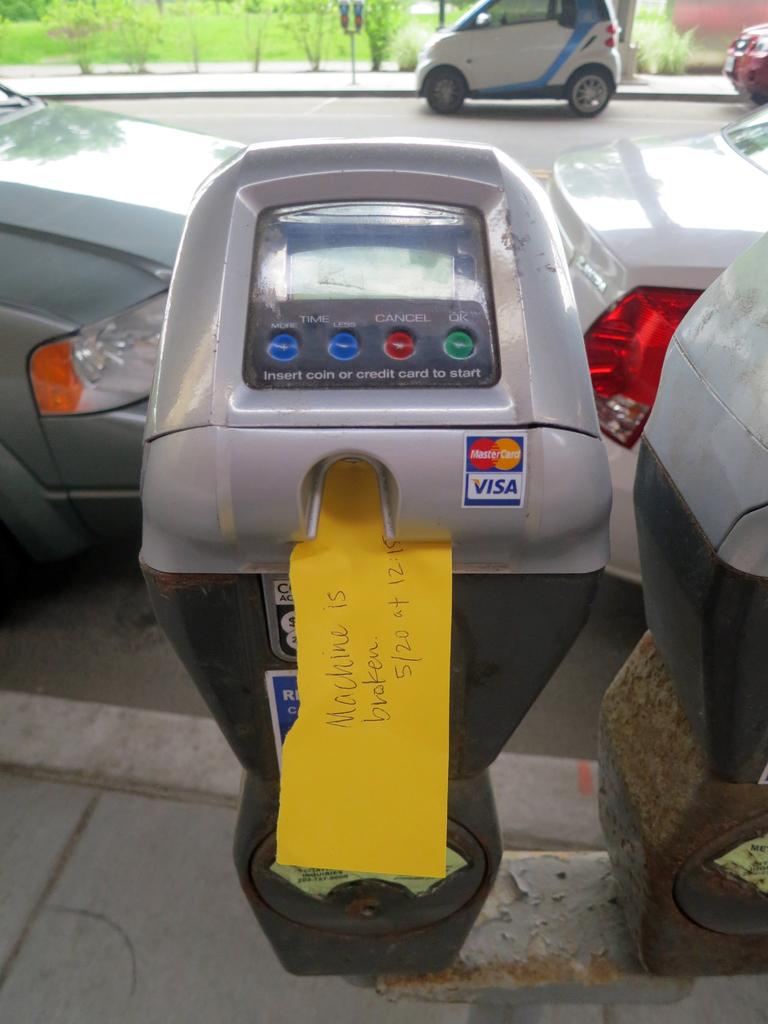<image>
Render a clear and concise summary of the photo. A parking meter was a car parked behind it and a note inside the meter stating the machine is broken with the date and time. 